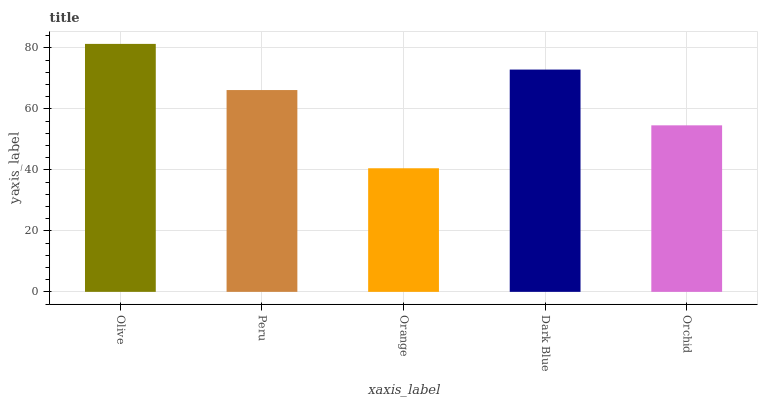Is Orange the minimum?
Answer yes or no. Yes. Is Olive the maximum?
Answer yes or no. Yes. Is Peru the minimum?
Answer yes or no. No. Is Peru the maximum?
Answer yes or no. No. Is Olive greater than Peru?
Answer yes or no. Yes. Is Peru less than Olive?
Answer yes or no. Yes. Is Peru greater than Olive?
Answer yes or no. No. Is Olive less than Peru?
Answer yes or no. No. Is Peru the high median?
Answer yes or no. Yes. Is Peru the low median?
Answer yes or no. Yes. Is Orchid the high median?
Answer yes or no. No. Is Olive the low median?
Answer yes or no. No. 